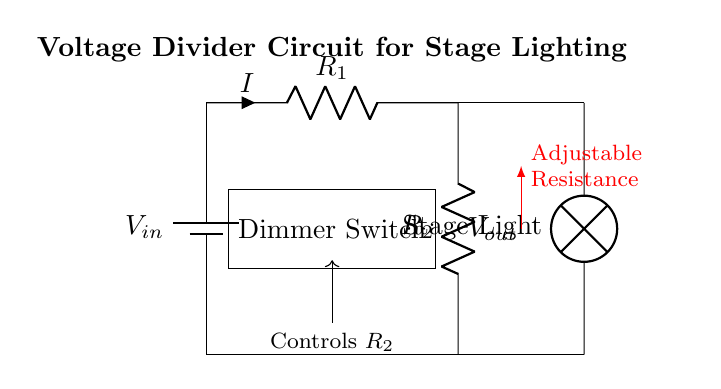What is the input voltage in the circuit? The input voltage is represented as V_in in the diagram, which is the voltage supplied by the battery.
Answer: V_in What does R_1 represent? R_1 represents the first resistor in the voltage divider circuit, which affects the output voltage based on its resistance value.
Answer: First resistor What is the purpose of R_2 in the circuit? R_2 is the second resistor in the voltage divider that adjusts the output voltage based on its value, allowing control of the lamp brightness.
Answer: Adjustable resistance What is the function of the dimmer switch? The dimmer switch controls the resistance of R_2, thus varying the output voltage and adjusting the brightness of the stage light.
Answer: Control of brightness What happens to V_out when R_2 is increased? When R_2 is increased, the output voltage V_out decreases due to the voltage divider rule, which states that the output voltage is a fraction of the input voltage proportional to the resistances.
Answer: V_out decreases What component directly lights the stage light? The component that directly lights the stage light is the lamp connected at the output of the circuit, which receives the adjusted voltage.
Answer: Lamp 